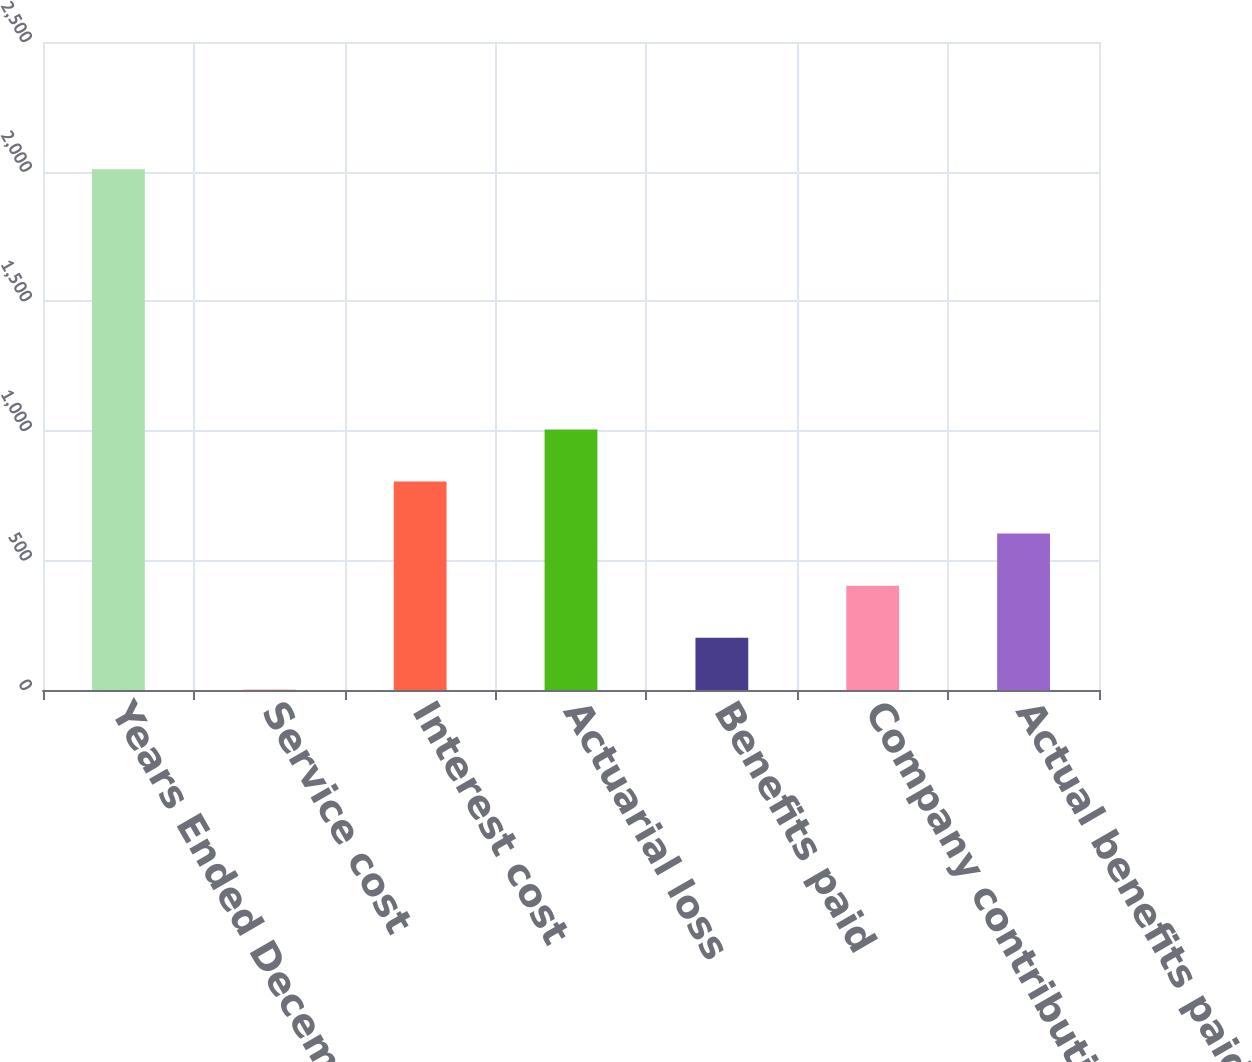Convert chart. <chart><loc_0><loc_0><loc_500><loc_500><bar_chart><fcel>Years Ended December 31<fcel>Service cost<fcel>Interest cost<fcel>Actuarial loss<fcel>Benefits paid<fcel>Company contribution<fcel>Actual benefits paid(b)<nl><fcel>2009<fcel>1<fcel>804.2<fcel>1005<fcel>201.8<fcel>402.6<fcel>603.4<nl></chart> 